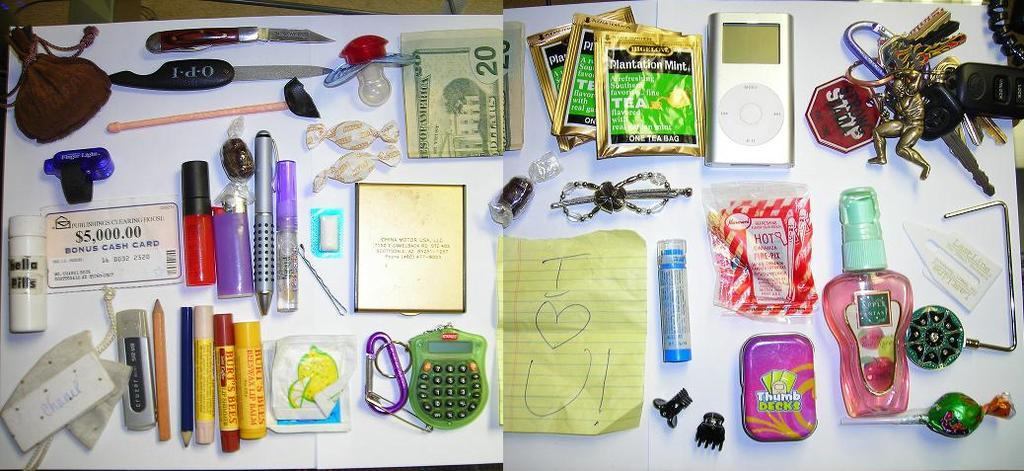What is the main object in the image? There is a paper in the image. What can be seen on the paper? There are pens, chocolates, currency, a keychain, and other items on the paper. What type of writing utensils are on the paper? There are pens on the paper. What else is present on the paper besides writing utensils? There are chocolates, currency, a keychain, and other items on the paper. How does the daughter interact with the insurance policy on the paper? There is no daughter or insurance policy present in the image. 